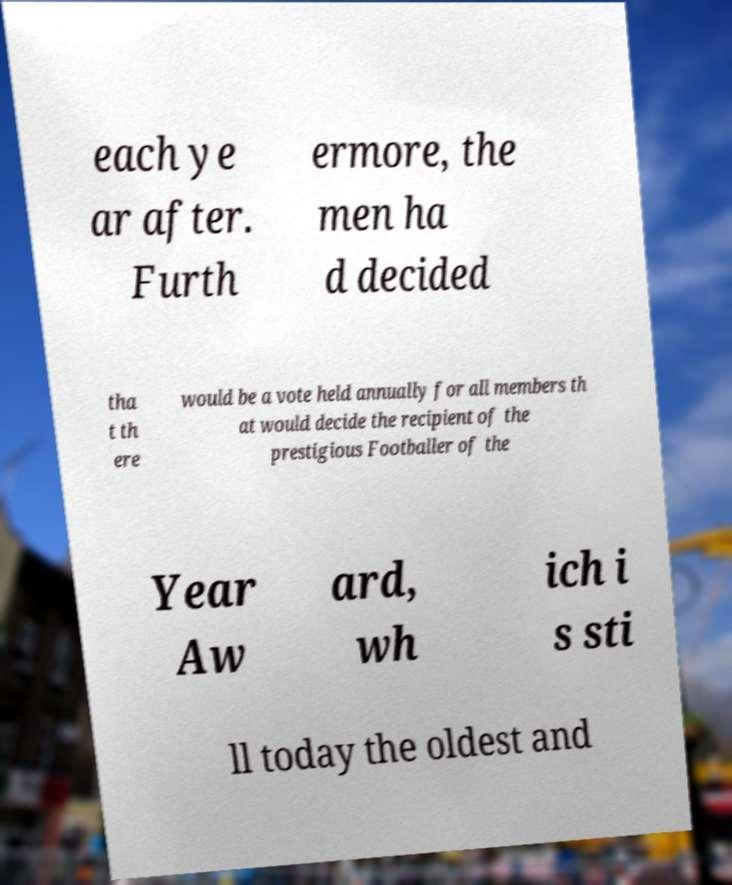Please identify and transcribe the text found in this image. each ye ar after. Furth ermore, the men ha d decided tha t th ere would be a vote held annually for all members th at would decide the recipient of the prestigious Footballer of the Year Aw ard, wh ich i s sti ll today the oldest and 